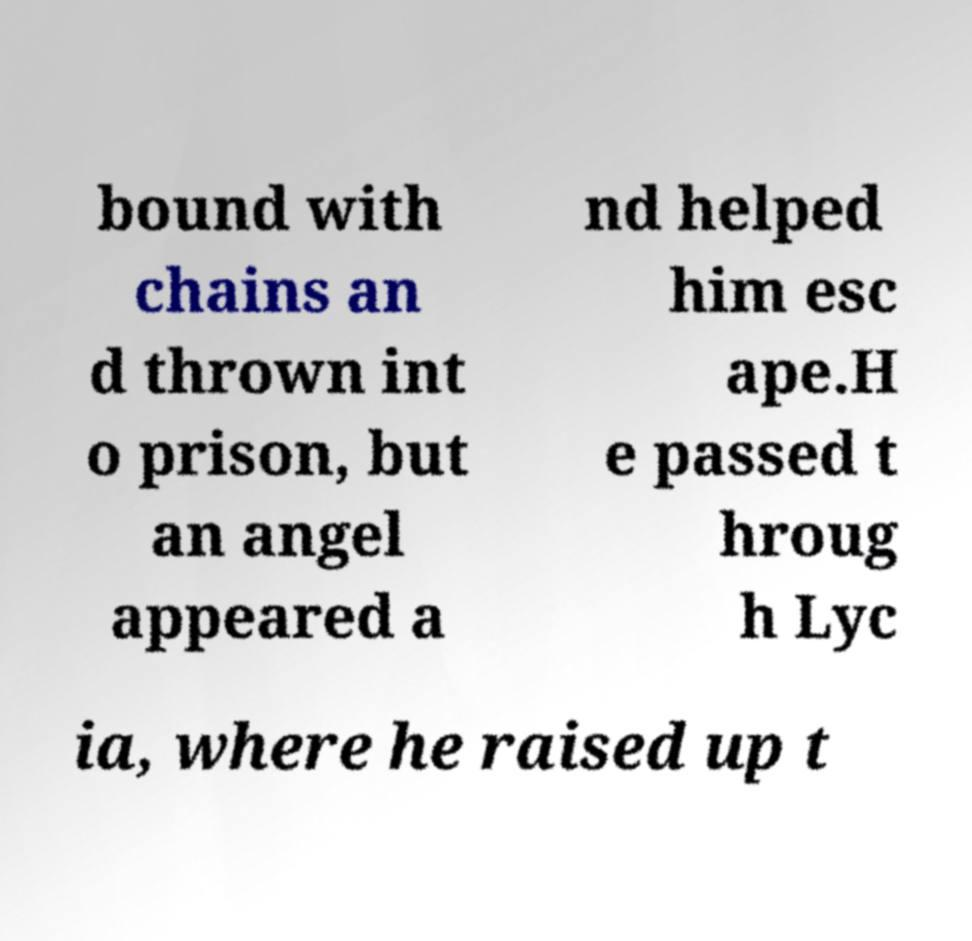Could you assist in decoding the text presented in this image and type it out clearly? bound with chains an d thrown int o prison, but an angel appeared a nd helped him esc ape.H e passed t hroug h Lyc ia, where he raised up t 